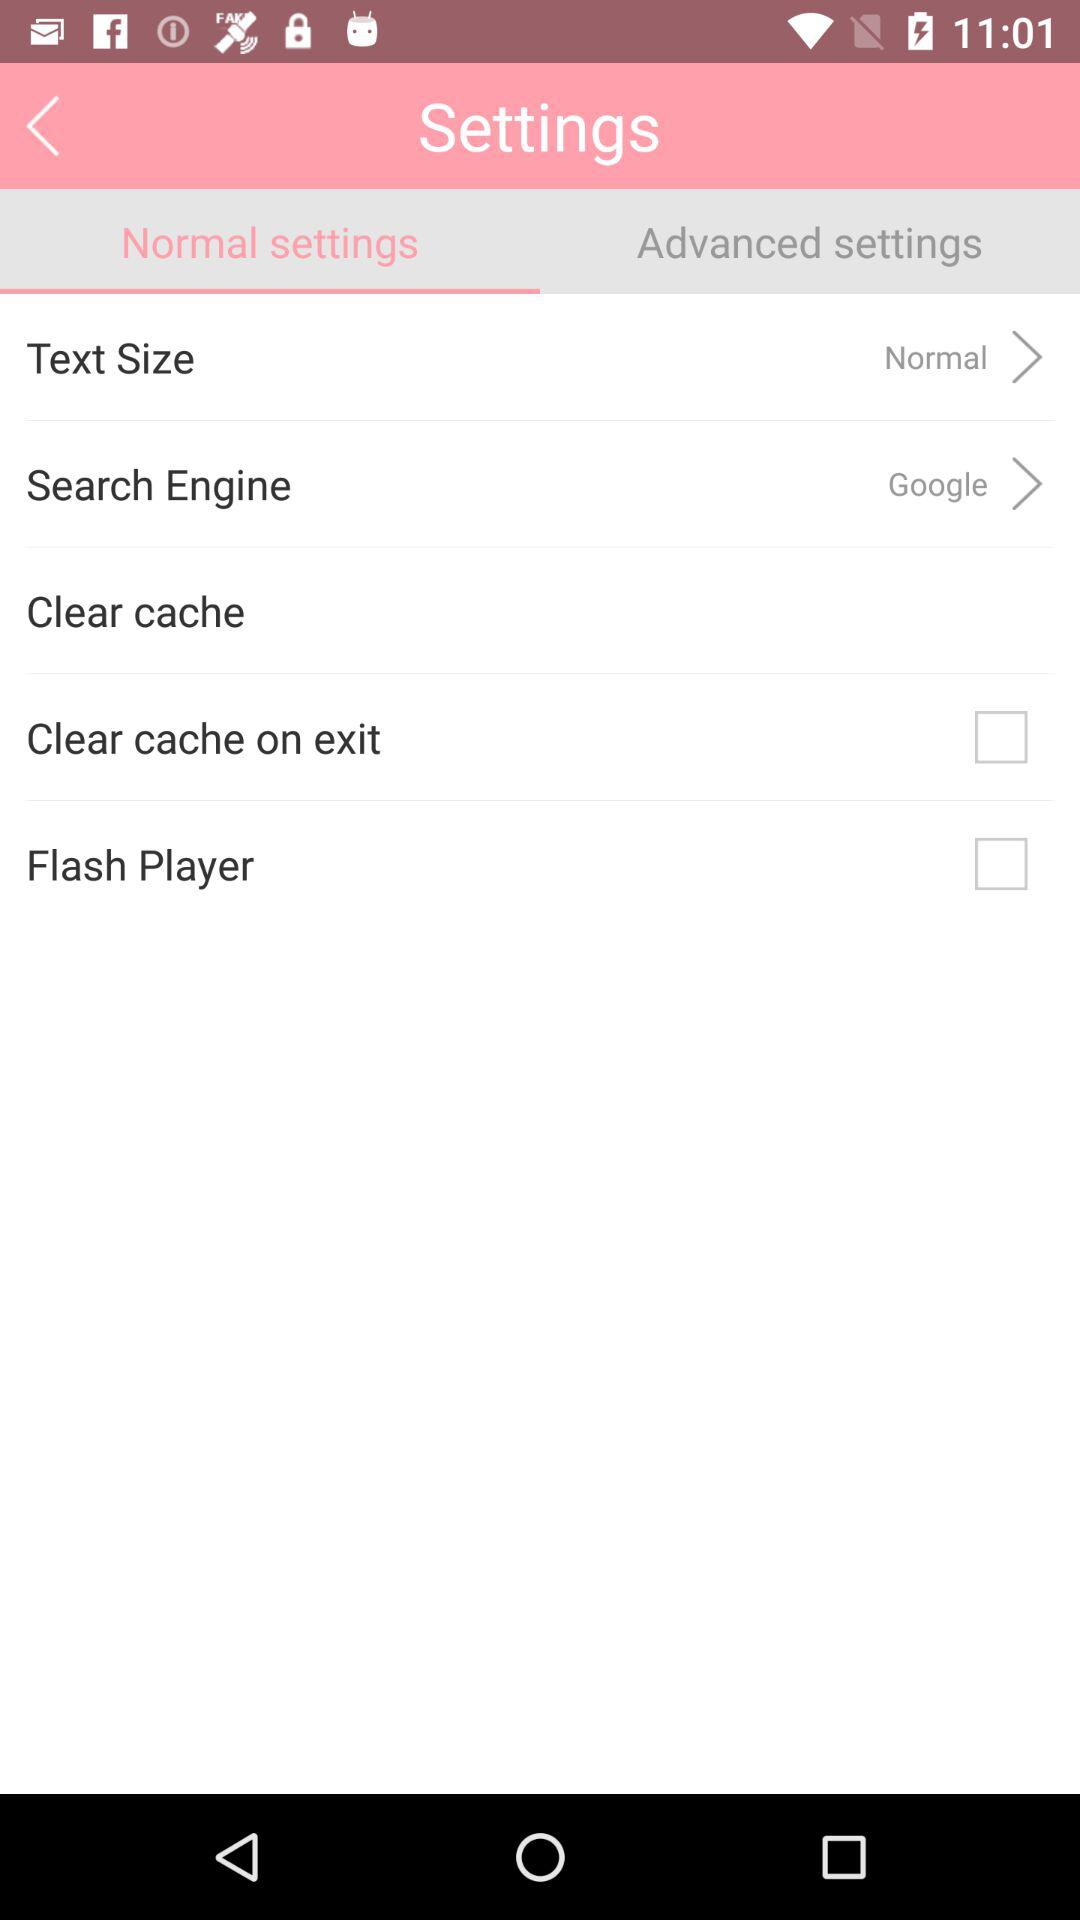Which tab is selected? The selected tab is "Normal settings". 